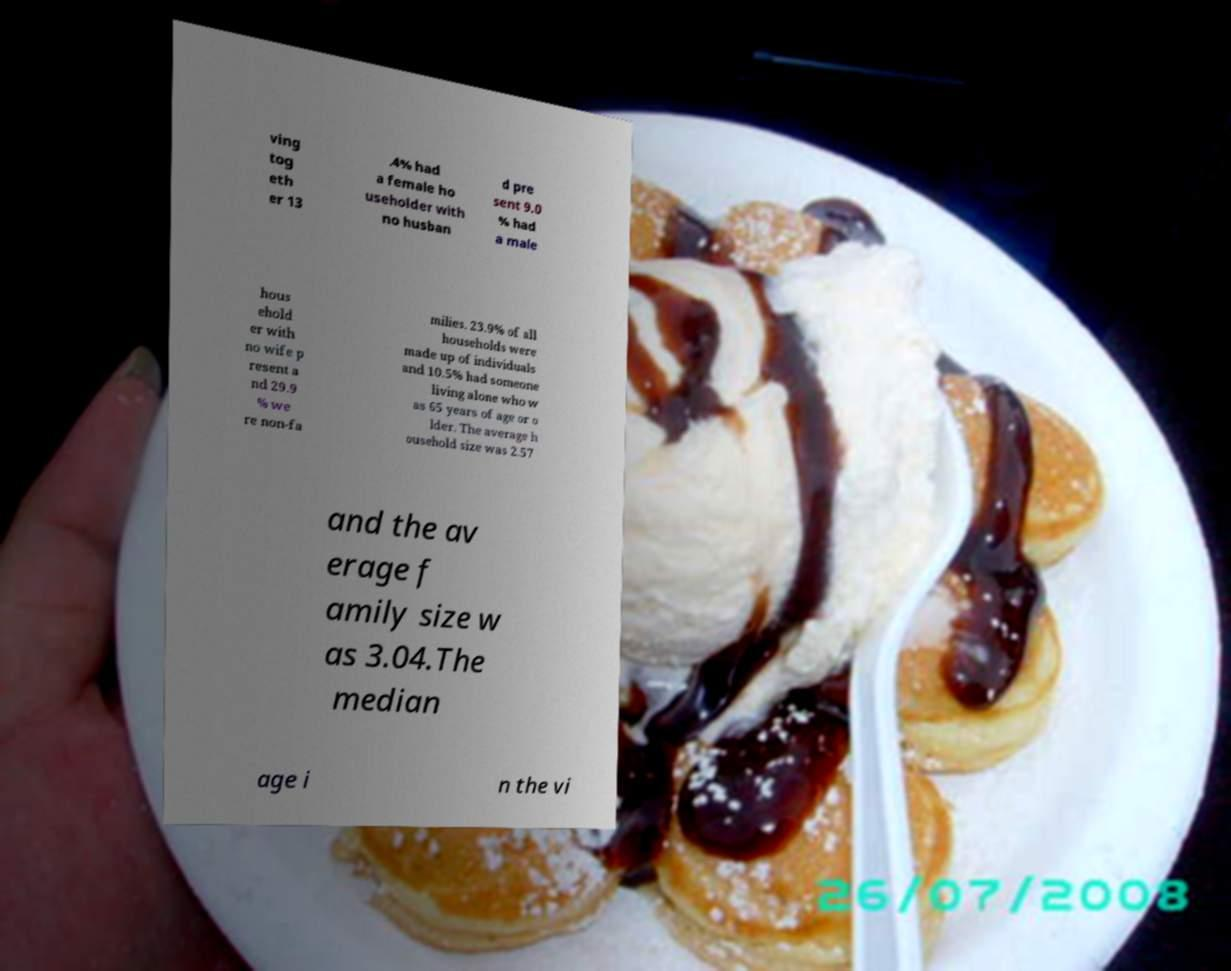Could you assist in decoding the text presented in this image and type it out clearly? ving tog eth er 13 .4% had a female ho useholder with no husban d pre sent 9.0 % had a male hous ehold er with no wife p resent a nd 29.9 % we re non-fa milies. 23.9% of all households were made up of individuals and 10.5% had someone living alone who w as 65 years of age or o lder. The average h ousehold size was 2.57 and the av erage f amily size w as 3.04.The median age i n the vi 